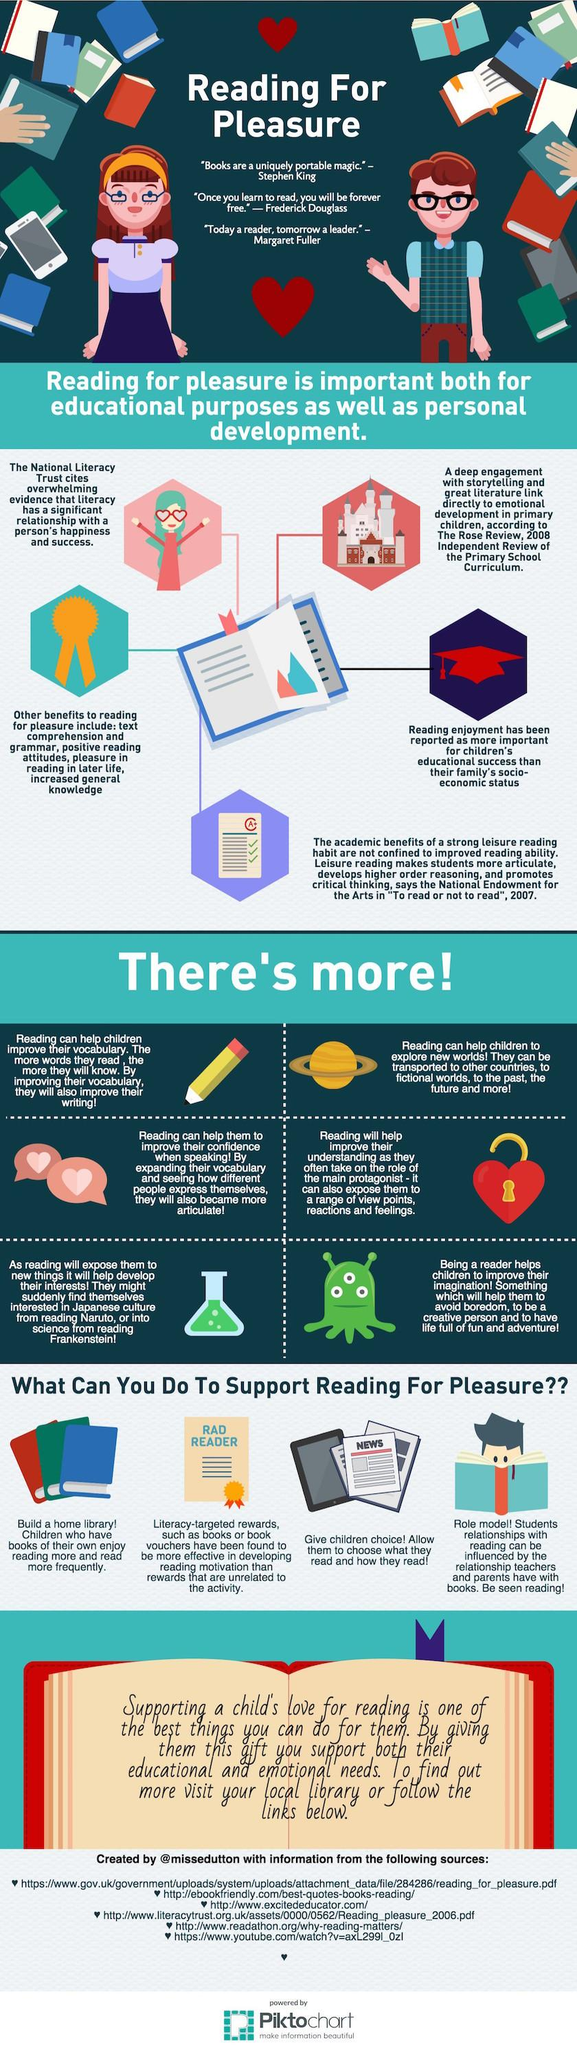Specify some key components in this picture. The infographic depicts the planet Saturn, rather than Mars, Earth, or any other planet. The liquid in the measuring flask is green. The color of the graduation cap is red. The infographic depicts 4 children. Six sources are listed at the bottom. 